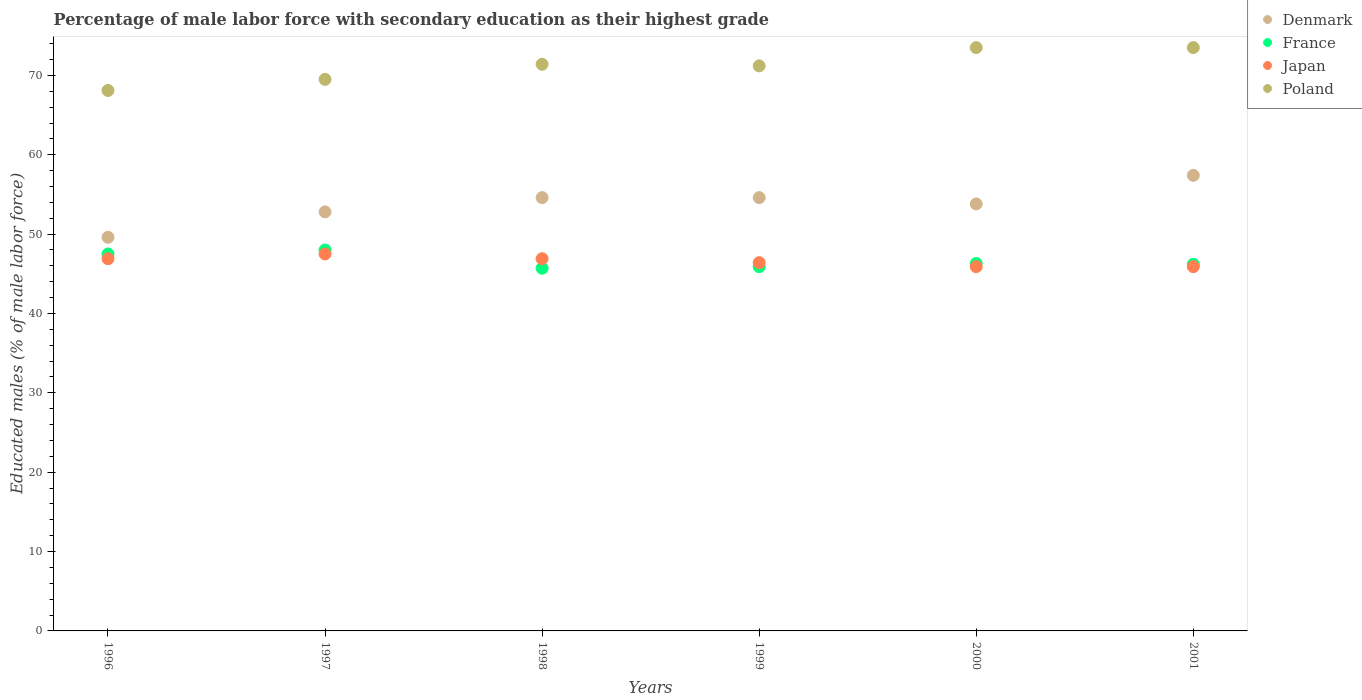How many different coloured dotlines are there?
Your answer should be very brief. 4. What is the percentage of male labor force with secondary education in Japan in 1996?
Your answer should be very brief. 46.9. Across all years, what is the maximum percentage of male labor force with secondary education in Poland?
Give a very brief answer. 73.5. Across all years, what is the minimum percentage of male labor force with secondary education in Denmark?
Provide a succinct answer. 49.6. In which year was the percentage of male labor force with secondary education in Denmark maximum?
Offer a terse response. 2001. What is the total percentage of male labor force with secondary education in Poland in the graph?
Provide a short and direct response. 427.2. What is the difference between the percentage of male labor force with secondary education in Poland in 1999 and that in 2001?
Your answer should be compact. -2.3. What is the difference between the percentage of male labor force with secondary education in Denmark in 1997 and the percentage of male labor force with secondary education in Poland in 1999?
Keep it short and to the point. -18.4. What is the average percentage of male labor force with secondary education in Japan per year?
Your response must be concise. 46.58. In the year 2001, what is the difference between the percentage of male labor force with secondary education in France and percentage of male labor force with secondary education in Japan?
Offer a terse response. 0.3. In how many years, is the percentage of male labor force with secondary education in Japan greater than 6 %?
Make the answer very short. 6. What is the ratio of the percentage of male labor force with secondary education in Poland in 2000 to that in 2001?
Provide a short and direct response. 1. What is the difference between the highest and the lowest percentage of male labor force with secondary education in Poland?
Provide a succinct answer. 5.4. Is the sum of the percentage of male labor force with secondary education in France in 1997 and 2001 greater than the maximum percentage of male labor force with secondary education in Poland across all years?
Your response must be concise. Yes. Is it the case that in every year, the sum of the percentage of male labor force with secondary education in Poland and percentage of male labor force with secondary education in France  is greater than the percentage of male labor force with secondary education in Japan?
Your answer should be compact. Yes. Is the percentage of male labor force with secondary education in Poland strictly greater than the percentage of male labor force with secondary education in France over the years?
Give a very brief answer. Yes. What is the difference between two consecutive major ticks on the Y-axis?
Your answer should be very brief. 10. Are the values on the major ticks of Y-axis written in scientific E-notation?
Your response must be concise. No. Does the graph contain any zero values?
Provide a short and direct response. No. How are the legend labels stacked?
Offer a terse response. Vertical. What is the title of the graph?
Make the answer very short. Percentage of male labor force with secondary education as their highest grade. Does "Indonesia" appear as one of the legend labels in the graph?
Offer a very short reply. No. What is the label or title of the X-axis?
Provide a succinct answer. Years. What is the label or title of the Y-axis?
Your response must be concise. Educated males (% of male labor force). What is the Educated males (% of male labor force) in Denmark in 1996?
Offer a terse response. 49.6. What is the Educated males (% of male labor force) in France in 1996?
Give a very brief answer. 47.5. What is the Educated males (% of male labor force) of Japan in 1996?
Give a very brief answer. 46.9. What is the Educated males (% of male labor force) of Poland in 1996?
Provide a short and direct response. 68.1. What is the Educated males (% of male labor force) of Denmark in 1997?
Offer a very short reply. 52.8. What is the Educated males (% of male labor force) in Japan in 1997?
Provide a succinct answer. 47.5. What is the Educated males (% of male labor force) of Poland in 1997?
Your response must be concise. 69.5. What is the Educated males (% of male labor force) of Denmark in 1998?
Offer a terse response. 54.6. What is the Educated males (% of male labor force) in France in 1998?
Your response must be concise. 45.7. What is the Educated males (% of male labor force) of Japan in 1998?
Provide a short and direct response. 46.9. What is the Educated males (% of male labor force) in Poland in 1998?
Your response must be concise. 71.4. What is the Educated males (% of male labor force) of Denmark in 1999?
Make the answer very short. 54.6. What is the Educated males (% of male labor force) of France in 1999?
Your answer should be compact. 45.9. What is the Educated males (% of male labor force) in Japan in 1999?
Provide a succinct answer. 46.4. What is the Educated males (% of male labor force) in Poland in 1999?
Offer a terse response. 71.2. What is the Educated males (% of male labor force) of Denmark in 2000?
Your answer should be compact. 53.8. What is the Educated males (% of male labor force) in France in 2000?
Provide a short and direct response. 46.3. What is the Educated males (% of male labor force) in Japan in 2000?
Give a very brief answer. 45.9. What is the Educated males (% of male labor force) in Poland in 2000?
Provide a succinct answer. 73.5. What is the Educated males (% of male labor force) in Denmark in 2001?
Ensure brevity in your answer.  57.4. What is the Educated males (% of male labor force) of France in 2001?
Provide a short and direct response. 46.2. What is the Educated males (% of male labor force) in Japan in 2001?
Your answer should be very brief. 45.9. What is the Educated males (% of male labor force) of Poland in 2001?
Provide a succinct answer. 73.5. Across all years, what is the maximum Educated males (% of male labor force) in Denmark?
Your answer should be compact. 57.4. Across all years, what is the maximum Educated males (% of male labor force) in Japan?
Provide a succinct answer. 47.5. Across all years, what is the maximum Educated males (% of male labor force) in Poland?
Provide a succinct answer. 73.5. Across all years, what is the minimum Educated males (% of male labor force) in Denmark?
Provide a succinct answer. 49.6. Across all years, what is the minimum Educated males (% of male labor force) of France?
Keep it short and to the point. 45.7. Across all years, what is the minimum Educated males (% of male labor force) in Japan?
Provide a succinct answer. 45.9. Across all years, what is the minimum Educated males (% of male labor force) in Poland?
Keep it short and to the point. 68.1. What is the total Educated males (% of male labor force) of Denmark in the graph?
Keep it short and to the point. 322.8. What is the total Educated males (% of male labor force) of France in the graph?
Your answer should be very brief. 279.6. What is the total Educated males (% of male labor force) in Japan in the graph?
Offer a terse response. 279.5. What is the total Educated males (% of male labor force) in Poland in the graph?
Offer a very short reply. 427.2. What is the difference between the Educated males (% of male labor force) of Japan in 1996 and that in 1997?
Give a very brief answer. -0.6. What is the difference between the Educated males (% of male labor force) in Poland in 1996 and that in 1997?
Give a very brief answer. -1.4. What is the difference between the Educated males (% of male labor force) of Denmark in 1996 and that in 1998?
Offer a terse response. -5. What is the difference between the Educated males (% of male labor force) of France in 1996 and that in 1998?
Your response must be concise. 1.8. What is the difference between the Educated males (% of male labor force) in Denmark in 1996 and that in 1999?
Offer a very short reply. -5. What is the difference between the Educated males (% of male labor force) of France in 1996 and that in 1999?
Make the answer very short. 1.6. What is the difference between the Educated males (% of male labor force) in Japan in 1996 and that in 1999?
Your answer should be very brief. 0.5. What is the difference between the Educated males (% of male labor force) in Poland in 1996 and that in 1999?
Provide a short and direct response. -3.1. What is the difference between the Educated males (% of male labor force) of Denmark in 1996 and that in 2000?
Your answer should be compact. -4.2. What is the difference between the Educated males (% of male labor force) of France in 1996 and that in 2000?
Keep it short and to the point. 1.2. What is the difference between the Educated males (% of male labor force) in Denmark in 1996 and that in 2001?
Keep it short and to the point. -7.8. What is the difference between the Educated males (% of male labor force) of France in 1996 and that in 2001?
Provide a short and direct response. 1.3. What is the difference between the Educated males (% of male labor force) in Denmark in 1997 and that in 1998?
Ensure brevity in your answer.  -1.8. What is the difference between the Educated males (% of male labor force) of Japan in 1997 and that in 1998?
Keep it short and to the point. 0.6. What is the difference between the Educated males (% of male labor force) in France in 1997 and that in 1999?
Offer a terse response. 2.1. What is the difference between the Educated males (% of male labor force) in Japan in 1997 and that in 1999?
Keep it short and to the point. 1.1. What is the difference between the Educated males (% of male labor force) in Poland in 1997 and that in 1999?
Make the answer very short. -1.7. What is the difference between the Educated males (% of male labor force) of Denmark in 1997 and that in 2001?
Ensure brevity in your answer.  -4.6. What is the difference between the Educated males (% of male labor force) of Japan in 1997 and that in 2001?
Provide a succinct answer. 1.6. What is the difference between the Educated males (% of male labor force) of Poland in 1997 and that in 2001?
Offer a very short reply. -4. What is the difference between the Educated males (% of male labor force) in Poland in 1998 and that in 1999?
Your response must be concise. 0.2. What is the difference between the Educated males (% of male labor force) of France in 1998 and that in 2000?
Offer a very short reply. -0.6. What is the difference between the Educated males (% of male labor force) in Japan in 1998 and that in 2000?
Offer a very short reply. 1. What is the difference between the Educated males (% of male labor force) in Poland in 1998 and that in 2000?
Make the answer very short. -2.1. What is the difference between the Educated males (% of male labor force) in Denmark in 1998 and that in 2001?
Your answer should be very brief. -2.8. What is the difference between the Educated males (% of male labor force) of France in 1998 and that in 2001?
Provide a short and direct response. -0.5. What is the difference between the Educated males (% of male labor force) of France in 1999 and that in 2000?
Offer a very short reply. -0.4. What is the difference between the Educated males (% of male labor force) of Japan in 1999 and that in 2000?
Provide a short and direct response. 0.5. What is the difference between the Educated males (% of male labor force) in Poland in 1999 and that in 2000?
Offer a very short reply. -2.3. What is the difference between the Educated males (% of male labor force) in Denmark in 1999 and that in 2001?
Give a very brief answer. -2.8. What is the difference between the Educated males (% of male labor force) in Poland in 1999 and that in 2001?
Provide a succinct answer. -2.3. What is the difference between the Educated males (% of male labor force) in Denmark in 2000 and that in 2001?
Provide a short and direct response. -3.6. What is the difference between the Educated males (% of male labor force) in Japan in 2000 and that in 2001?
Your answer should be very brief. 0. What is the difference between the Educated males (% of male labor force) of Denmark in 1996 and the Educated males (% of male labor force) of France in 1997?
Ensure brevity in your answer.  1.6. What is the difference between the Educated males (% of male labor force) in Denmark in 1996 and the Educated males (% of male labor force) in Japan in 1997?
Provide a short and direct response. 2.1. What is the difference between the Educated males (% of male labor force) of Denmark in 1996 and the Educated males (% of male labor force) of Poland in 1997?
Ensure brevity in your answer.  -19.9. What is the difference between the Educated males (% of male labor force) in France in 1996 and the Educated males (% of male labor force) in Japan in 1997?
Provide a short and direct response. 0. What is the difference between the Educated males (% of male labor force) of France in 1996 and the Educated males (% of male labor force) of Poland in 1997?
Give a very brief answer. -22. What is the difference between the Educated males (% of male labor force) in Japan in 1996 and the Educated males (% of male labor force) in Poland in 1997?
Provide a succinct answer. -22.6. What is the difference between the Educated males (% of male labor force) in Denmark in 1996 and the Educated males (% of male labor force) in France in 1998?
Make the answer very short. 3.9. What is the difference between the Educated males (% of male labor force) of Denmark in 1996 and the Educated males (% of male labor force) of Poland in 1998?
Your answer should be compact. -21.8. What is the difference between the Educated males (% of male labor force) in France in 1996 and the Educated males (% of male labor force) in Japan in 1998?
Provide a short and direct response. 0.6. What is the difference between the Educated males (% of male labor force) in France in 1996 and the Educated males (% of male labor force) in Poland in 1998?
Provide a succinct answer. -23.9. What is the difference between the Educated males (% of male labor force) in Japan in 1996 and the Educated males (% of male labor force) in Poland in 1998?
Your answer should be very brief. -24.5. What is the difference between the Educated males (% of male labor force) in Denmark in 1996 and the Educated males (% of male labor force) in France in 1999?
Offer a terse response. 3.7. What is the difference between the Educated males (% of male labor force) of Denmark in 1996 and the Educated males (% of male labor force) of Poland in 1999?
Keep it short and to the point. -21.6. What is the difference between the Educated males (% of male labor force) of France in 1996 and the Educated males (% of male labor force) of Japan in 1999?
Offer a very short reply. 1.1. What is the difference between the Educated males (% of male labor force) in France in 1996 and the Educated males (% of male labor force) in Poland in 1999?
Your answer should be compact. -23.7. What is the difference between the Educated males (% of male labor force) of Japan in 1996 and the Educated males (% of male labor force) of Poland in 1999?
Keep it short and to the point. -24.3. What is the difference between the Educated males (% of male labor force) in Denmark in 1996 and the Educated males (% of male labor force) in Japan in 2000?
Offer a very short reply. 3.7. What is the difference between the Educated males (% of male labor force) in Denmark in 1996 and the Educated males (% of male labor force) in Poland in 2000?
Your answer should be compact. -23.9. What is the difference between the Educated males (% of male labor force) in France in 1996 and the Educated males (% of male labor force) in Poland in 2000?
Provide a short and direct response. -26. What is the difference between the Educated males (% of male labor force) in Japan in 1996 and the Educated males (% of male labor force) in Poland in 2000?
Offer a terse response. -26.6. What is the difference between the Educated males (% of male labor force) of Denmark in 1996 and the Educated males (% of male labor force) of France in 2001?
Provide a short and direct response. 3.4. What is the difference between the Educated males (% of male labor force) in Denmark in 1996 and the Educated males (% of male labor force) in Poland in 2001?
Offer a very short reply. -23.9. What is the difference between the Educated males (% of male labor force) of France in 1996 and the Educated males (% of male labor force) of Poland in 2001?
Your response must be concise. -26. What is the difference between the Educated males (% of male labor force) of Japan in 1996 and the Educated males (% of male labor force) of Poland in 2001?
Offer a very short reply. -26.6. What is the difference between the Educated males (% of male labor force) in Denmark in 1997 and the Educated males (% of male labor force) in Poland in 1998?
Offer a very short reply. -18.6. What is the difference between the Educated males (% of male labor force) in France in 1997 and the Educated males (% of male labor force) in Japan in 1998?
Provide a short and direct response. 1.1. What is the difference between the Educated males (% of male labor force) of France in 1997 and the Educated males (% of male labor force) of Poland in 1998?
Offer a terse response. -23.4. What is the difference between the Educated males (% of male labor force) of Japan in 1997 and the Educated males (% of male labor force) of Poland in 1998?
Make the answer very short. -23.9. What is the difference between the Educated males (% of male labor force) in Denmark in 1997 and the Educated males (% of male labor force) in France in 1999?
Ensure brevity in your answer.  6.9. What is the difference between the Educated males (% of male labor force) of Denmark in 1997 and the Educated males (% of male labor force) of Poland in 1999?
Keep it short and to the point. -18.4. What is the difference between the Educated males (% of male labor force) of France in 1997 and the Educated males (% of male labor force) of Japan in 1999?
Ensure brevity in your answer.  1.6. What is the difference between the Educated males (% of male labor force) in France in 1997 and the Educated males (% of male labor force) in Poland in 1999?
Provide a succinct answer. -23.2. What is the difference between the Educated males (% of male labor force) in Japan in 1997 and the Educated males (% of male labor force) in Poland in 1999?
Make the answer very short. -23.7. What is the difference between the Educated males (% of male labor force) of Denmark in 1997 and the Educated males (% of male labor force) of Japan in 2000?
Your answer should be compact. 6.9. What is the difference between the Educated males (% of male labor force) of Denmark in 1997 and the Educated males (% of male labor force) of Poland in 2000?
Provide a succinct answer. -20.7. What is the difference between the Educated males (% of male labor force) of France in 1997 and the Educated males (% of male labor force) of Japan in 2000?
Offer a terse response. 2.1. What is the difference between the Educated males (% of male labor force) of France in 1997 and the Educated males (% of male labor force) of Poland in 2000?
Ensure brevity in your answer.  -25.5. What is the difference between the Educated males (% of male labor force) in Denmark in 1997 and the Educated males (% of male labor force) in France in 2001?
Offer a very short reply. 6.6. What is the difference between the Educated males (% of male labor force) in Denmark in 1997 and the Educated males (% of male labor force) in Japan in 2001?
Offer a terse response. 6.9. What is the difference between the Educated males (% of male labor force) in Denmark in 1997 and the Educated males (% of male labor force) in Poland in 2001?
Give a very brief answer. -20.7. What is the difference between the Educated males (% of male labor force) of France in 1997 and the Educated males (% of male labor force) of Japan in 2001?
Make the answer very short. 2.1. What is the difference between the Educated males (% of male labor force) in France in 1997 and the Educated males (% of male labor force) in Poland in 2001?
Give a very brief answer. -25.5. What is the difference between the Educated males (% of male labor force) in Japan in 1997 and the Educated males (% of male labor force) in Poland in 2001?
Ensure brevity in your answer.  -26. What is the difference between the Educated males (% of male labor force) of Denmark in 1998 and the Educated males (% of male labor force) of Poland in 1999?
Ensure brevity in your answer.  -16.6. What is the difference between the Educated males (% of male labor force) of France in 1998 and the Educated males (% of male labor force) of Poland in 1999?
Your answer should be compact. -25.5. What is the difference between the Educated males (% of male labor force) of Japan in 1998 and the Educated males (% of male labor force) of Poland in 1999?
Keep it short and to the point. -24.3. What is the difference between the Educated males (% of male labor force) in Denmark in 1998 and the Educated males (% of male labor force) in France in 2000?
Provide a short and direct response. 8.3. What is the difference between the Educated males (% of male labor force) of Denmark in 1998 and the Educated males (% of male labor force) of Japan in 2000?
Ensure brevity in your answer.  8.7. What is the difference between the Educated males (% of male labor force) of Denmark in 1998 and the Educated males (% of male labor force) of Poland in 2000?
Offer a terse response. -18.9. What is the difference between the Educated males (% of male labor force) in France in 1998 and the Educated males (% of male labor force) in Poland in 2000?
Provide a short and direct response. -27.8. What is the difference between the Educated males (% of male labor force) in Japan in 1998 and the Educated males (% of male labor force) in Poland in 2000?
Offer a very short reply. -26.6. What is the difference between the Educated males (% of male labor force) in Denmark in 1998 and the Educated males (% of male labor force) in France in 2001?
Your response must be concise. 8.4. What is the difference between the Educated males (% of male labor force) in Denmark in 1998 and the Educated males (% of male labor force) in Japan in 2001?
Offer a terse response. 8.7. What is the difference between the Educated males (% of male labor force) of Denmark in 1998 and the Educated males (% of male labor force) of Poland in 2001?
Your response must be concise. -18.9. What is the difference between the Educated males (% of male labor force) in France in 1998 and the Educated males (% of male labor force) in Poland in 2001?
Your answer should be compact. -27.8. What is the difference between the Educated males (% of male labor force) of Japan in 1998 and the Educated males (% of male labor force) of Poland in 2001?
Your response must be concise. -26.6. What is the difference between the Educated males (% of male labor force) of Denmark in 1999 and the Educated males (% of male labor force) of Poland in 2000?
Provide a short and direct response. -18.9. What is the difference between the Educated males (% of male labor force) of France in 1999 and the Educated males (% of male labor force) of Japan in 2000?
Provide a short and direct response. 0. What is the difference between the Educated males (% of male labor force) in France in 1999 and the Educated males (% of male labor force) in Poland in 2000?
Your response must be concise. -27.6. What is the difference between the Educated males (% of male labor force) of Japan in 1999 and the Educated males (% of male labor force) of Poland in 2000?
Give a very brief answer. -27.1. What is the difference between the Educated males (% of male labor force) of Denmark in 1999 and the Educated males (% of male labor force) of Japan in 2001?
Offer a very short reply. 8.7. What is the difference between the Educated males (% of male labor force) of Denmark in 1999 and the Educated males (% of male labor force) of Poland in 2001?
Offer a very short reply. -18.9. What is the difference between the Educated males (% of male labor force) in France in 1999 and the Educated males (% of male labor force) in Japan in 2001?
Offer a terse response. 0. What is the difference between the Educated males (% of male labor force) of France in 1999 and the Educated males (% of male labor force) of Poland in 2001?
Offer a very short reply. -27.6. What is the difference between the Educated males (% of male labor force) of Japan in 1999 and the Educated males (% of male labor force) of Poland in 2001?
Ensure brevity in your answer.  -27.1. What is the difference between the Educated males (% of male labor force) of Denmark in 2000 and the Educated males (% of male labor force) of France in 2001?
Offer a terse response. 7.6. What is the difference between the Educated males (% of male labor force) in Denmark in 2000 and the Educated males (% of male labor force) in Poland in 2001?
Your answer should be compact. -19.7. What is the difference between the Educated males (% of male labor force) in France in 2000 and the Educated males (% of male labor force) in Poland in 2001?
Your response must be concise. -27.2. What is the difference between the Educated males (% of male labor force) of Japan in 2000 and the Educated males (% of male labor force) of Poland in 2001?
Provide a succinct answer. -27.6. What is the average Educated males (% of male labor force) in Denmark per year?
Your answer should be compact. 53.8. What is the average Educated males (% of male labor force) in France per year?
Your answer should be very brief. 46.6. What is the average Educated males (% of male labor force) of Japan per year?
Provide a short and direct response. 46.58. What is the average Educated males (% of male labor force) of Poland per year?
Your answer should be very brief. 71.2. In the year 1996, what is the difference between the Educated males (% of male labor force) of Denmark and Educated males (% of male labor force) of Japan?
Your answer should be very brief. 2.7. In the year 1996, what is the difference between the Educated males (% of male labor force) of Denmark and Educated males (% of male labor force) of Poland?
Offer a terse response. -18.5. In the year 1996, what is the difference between the Educated males (% of male labor force) of France and Educated males (% of male labor force) of Japan?
Offer a very short reply. 0.6. In the year 1996, what is the difference between the Educated males (% of male labor force) in France and Educated males (% of male labor force) in Poland?
Provide a succinct answer. -20.6. In the year 1996, what is the difference between the Educated males (% of male labor force) in Japan and Educated males (% of male labor force) in Poland?
Make the answer very short. -21.2. In the year 1997, what is the difference between the Educated males (% of male labor force) of Denmark and Educated males (% of male labor force) of France?
Offer a very short reply. 4.8. In the year 1997, what is the difference between the Educated males (% of male labor force) in Denmark and Educated males (% of male labor force) in Japan?
Your response must be concise. 5.3. In the year 1997, what is the difference between the Educated males (% of male labor force) of Denmark and Educated males (% of male labor force) of Poland?
Provide a succinct answer. -16.7. In the year 1997, what is the difference between the Educated males (% of male labor force) of France and Educated males (% of male labor force) of Poland?
Ensure brevity in your answer.  -21.5. In the year 1997, what is the difference between the Educated males (% of male labor force) of Japan and Educated males (% of male labor force) of Poland?
Make the answer very short. -22. In the year 1998, what is the difference between the Educated males (% of male labor force) of Denmark and Educated males (% of male labor force) of France?
Your response must be concise. 8.9. In the year 1998, what is the difference between the Educated males (% of male labor force) in Denmark and Educated males (% of male labor force) in Japan?
Your response must be concise. 7.7. In the year 1998, what is the difference between the Educated males (% of male labor force) in Denmark and Educated males (% of male labor force) in Poland?
Make the answer very short. -16.8. In the year 1998, what is the difference between the Educated males (% of male labor force) in France and Educated males (% of male labor force) in Poland?
Your answer should be very brief. -25.7. In the year 1998, what is the difference between the Educated males (% of male labor force) of Japan and Educated males (% of male labor force) of Poland?
Ensure brevity in your answer.  -24.5. In the year 1999, what is the difference between the Educated males (% of male labor force) of Denmark and Educated males (% of male labor force) of France?
Your response must be concise. 8.7. In the year 1999, what is the difference between the Educated males (% of male labor force) of Denmark and Educated males (% of male labor force) of Japan?
Keep it short and to the point. 8.2. In the year 1999, what is the difference between the Educated males (% of male labor force) of Denmark and Educated males (% of male labor force) of Poland?
Keep it short and to the point. -16.6. In the year 1999, what is the difference between the Educated males (% of male labor force) of France and Educated males (% of male labor force) of Japan?
Provide a succinct answer. -0.5. In the year 1999, what is the difference between the Educated males (% of male labor force) in France and Educated males (% of male labor force) in Poland?
Your answer should be compact. -25.3. In the year 1999, what is the difference between the Educated males (% of male labor force) of Japan and Educated males (% of male labor force) of Poland?
Offer a terse response. -24.8. In the year 2000, what is the difference between the Educated males (% of male labor force) in Denmark and Educated males (% of male labor force) in Japan?
Provide a succinct answer. 7.9. In the year 2000, what is the difference between the Educated males (% of male labor force) in Denmark and Educated males (% of male labor force) in Poland?
Your answer should be very brief. -19.7. In the year 2000, what is the difference between the Educated males (% of male labor force) of France and Educated males (% of male labor force) of Japan?
Your response must be concise. 0.4. In the year 2000, what is the difference between the Educated males (% of male labor force) of France and Educated males (% of male labor force) of Poland?
Your answer should be compact. -27.2. In the year 2000, what is the difference between the Educated males (% of male labor force) of Japan and Educated males (% of male labor force) of Poland?
Ensure brevity in your answer.  -27.6. In the year 2001, what is the difference between the Educated males (% of male labor force) in Denmark and Educated males (% of male labor force) in Poland?
Make the answer very short. -16.1. In the year 2001, what is the difference between the Educated males (% of male labor force) in France and Educated males (% of male labor force) in Poland?
Make the answer very short. -27.3. In the year 2001, what is the difference between the Educated males (% of male labor force) in Japan and Educated males (% of male labor force) in Poland?
Make the answer very short. -27.6. What is the ratio of the Educated males (% of male labor force) of Denmark in 1996 to that in 1997?
Ensure brevity in your answer.  0.94. What is the ratio of the Educated males (% of male labor force) of France in 1996 to that in 1997?
Give a very brief answer. 0.99. What is the ratio of the Educated males (% of male labor force) in Japan in 1996 to that in 1997?
Give a very brief answer. 0.99. What is the ratio of the Educated males (% of male labor force) in Poland in 1996 to that in 1997?
Make the answer very short. 0.98. What is the ratio of the Educated males (% of male labor force) in Denmark in 1996 to that in 1998?
Give a very brief answer. 0.91. What is the ratio of the Educated males (% of male labor force) of France in 1996 to that in 1998?
Your answer should be compact. 1.04. What is the ratio of the Educated males (% of male labor force) of Japan in 1996 to that in 1998?
Make the answer very short. 1. What is the ratio of the Educated males (% of male labor force) in Poland in 1996 to that in 1998?
Your response must be concise. 0.95. What is the ratio of the Educated males (% of male labor force) in Denmark in 1996 to that in 1999?
Provide a short and direct response. 0.91. What is the ratio of the Educated males (% of male labor force) in France in 1996 to that in 1999?
Provide a succinct answer. 1.03. What is the ratio of the Educated males (% of male labor force) in Japan in 1996 to that in 1999?
Keep it short and to the point. 1.01. What is the ratio of the Educated males (% of male labor force) of Poland in 1996 to that in 1999?
Your answer should be compact. 0.96. What is the ratio of the Educated males (% of male labor force) in Denmark in 1996 to that in 2000?
Offer a very short reply. 0.92. What is the ratio of the Educated males (% of male labor force) in France in 1996 to that in 2000?
Your response must be concise. 1.03. What is the ratio of the Educated males (% of male labor force) in Japan in 1996 to that in 2000?
Offer a terse response. 1.02. What is the ratio of the Educated males (% of male labor force) in Poland in 1996 to that in 2000?
Your answer should be compact. 0.93. What is the ratio of the Educated males (% of male labor force) of Denmark in 1996 to that in 2001?
Offer a very short reply. 0.86. What is the ratio of the Educated males (% of male labor force) of France in 1996 to that in 2001?
Your answer should be very brief. 1.03. What is the ratio of the Educated males (% of male labor force) in Japan in 1996 to that in 2001?
Make the answer very short. 1.02. What is the ratio of the Educated males (% of male labor force) of Poland in 1996 to that in 2001?
Make the answer very short. 0.93. What is the ratio of the Educated males (% of male labor force) of France in 1997 to that in 1998?
Offer a very short reply. 1.05. What is the ratio of the Educated males (% of male labor force) in Japan in 1997 to that in 1998?
Offer a terse response. 1.01. What is the ratio of the Educated males (% of male labor force) of Poland in 1997 to that in 1998?
Your answer should be compact. 0.97. What is the ratio of the Educated males (% of male labor force) of France in 1997 to that in 1999?
Provide a succinct answer. 1.05. What is the ratio of the Educated males (% of male labor force) of Japan in 1997 to that in 1999?
Provide a short and direct response. 1.02. What is the ratio of the Educated males (% of male labor force) of Poland in 1997 to that in 1999?
Provide a succinct answer. 0.98. What is the ratio of the Educated males (% of male labor force) of Denmark in 1997 to that in 2000?
Make the answer very short. 0.98. What is the ratio of the Educated males (% of male labor force) in France in 1997 to that in 2000?
Give a very brief answer. 1.04. What is the ratio of the Educated males (% of male labor force) of Japan in 1997 to that in 2000?
Offer a very short reply. 1.03. What is the ratio of the Educated males (% of male labor force) of Poland in 1997 to that in 2000?
Provide a short and direct response. 0.95. What is the ratio of the Educated males (% of male labor force) of Denmark in 1997 to that in 2001?
Provide a succinct answer. 0.92. What is the ratio of the Educated males (% of male labor force) in France in 1997 to that in 2001?
Keep it short and to the point. 1.04. What is the ratio of the Educated males (% of male labor force) of Japan in 1997 to that in 2001?
Give a very brief answer. 1.03. What is the ratio of the Educated males (% of male labor force) of Poland in 1997 to that in 2001?
Provide a succinct answer. 0.95. What is the ratio of the Educated males (% of male labor force) of Denmark in 1998 to that in 1999?
Provide a succinct answer. 1. What is the ratio of the Educated males (% of male labor force) in Japan in 1998 to that in 1999?
Provide a short and direct response. 1.01. What is the ratio of the Educated males (% of male labor force) in Denmark in 1998 to that in 2000?
Offer a terse response. 1.01. What is the ratio of the Educated males (% of male labor force) of France in 1998 to that in 2000?
Your answer should be compact. 0.99. What is the ratio of the Educated males (% of male labor force) of Japan in 1998 to that in 2000?
Offer a very short reply. 1.02. What is the ratio of the Educated males (% of male labor force) of Poland in 1998 to that in 2000?
Provide a succinct answer. 0.97. What is the ratio of the Educated males (% of male labor force) in Denmark in 1998 to that in 2001?
Give a very brief answer. 0.95. What is the ratio of the Educated males (% of male labor force) in Japan in 1998 to that in 2001?
Make the answer very short. 1.02. What is the ratio of the Educated males (% of male labor force) in Poland in 1998 to that in 2001?
Offer a terse response. 0.97. What is the ratio of the Educated males (% of male labor force) in Denmark in 1999 to that in 2000?
Make the answer very short. 1.01. What is the ratio of the Educated males (% of male labor force) of France in 1999 to that in 2000?
Give a very brief answer. 0.99. What is the ratio of the Educated males (% of male labor force) of Japan in 1999 to that in 2000?
Ensure brevity in your answer.  1.01. What is the ratio of the Educated males (% of male labor force) of Poland in 1999 to that in 2000?
Offer a very short reply. 0.97. What is the ratio of the Educated males (% of male labor force) of Denmark in 1999 to that in 2001?
Keep it short and to the point. 0.95. What is the ratio of the Educated males (% of male labor force) in France in 1999 to that in 2001?
Your response must be concise. 0.99. What is the ratio of the Educated males (% of male labor force) in Japan in 1999 to that in 2001?
Your response must be concise. 1.01. What is the ratio of the Educated males (% of male labor force) in Poland in 1999 to that in 2001?
Your answer should be compact. 0.97. What is the ratio of the Educated males (% of male labor force) in Denmark in 2000 to that in 2001?
Keep it short and to the point. 0.94. What is the ratio of the Educated males (% of male labor force) in Japan in 2000 to that in 2001?
Provide a short and direct response. 1. What is the ratio of the Educated males (% of male labor force) of Poland in 2000 to that in 2001?
Make the answer very short. 1. What is the difference between the highest and the lowest Educated males (% of male labor force) in Denmark?
Offer a very short reply. 7.8. 